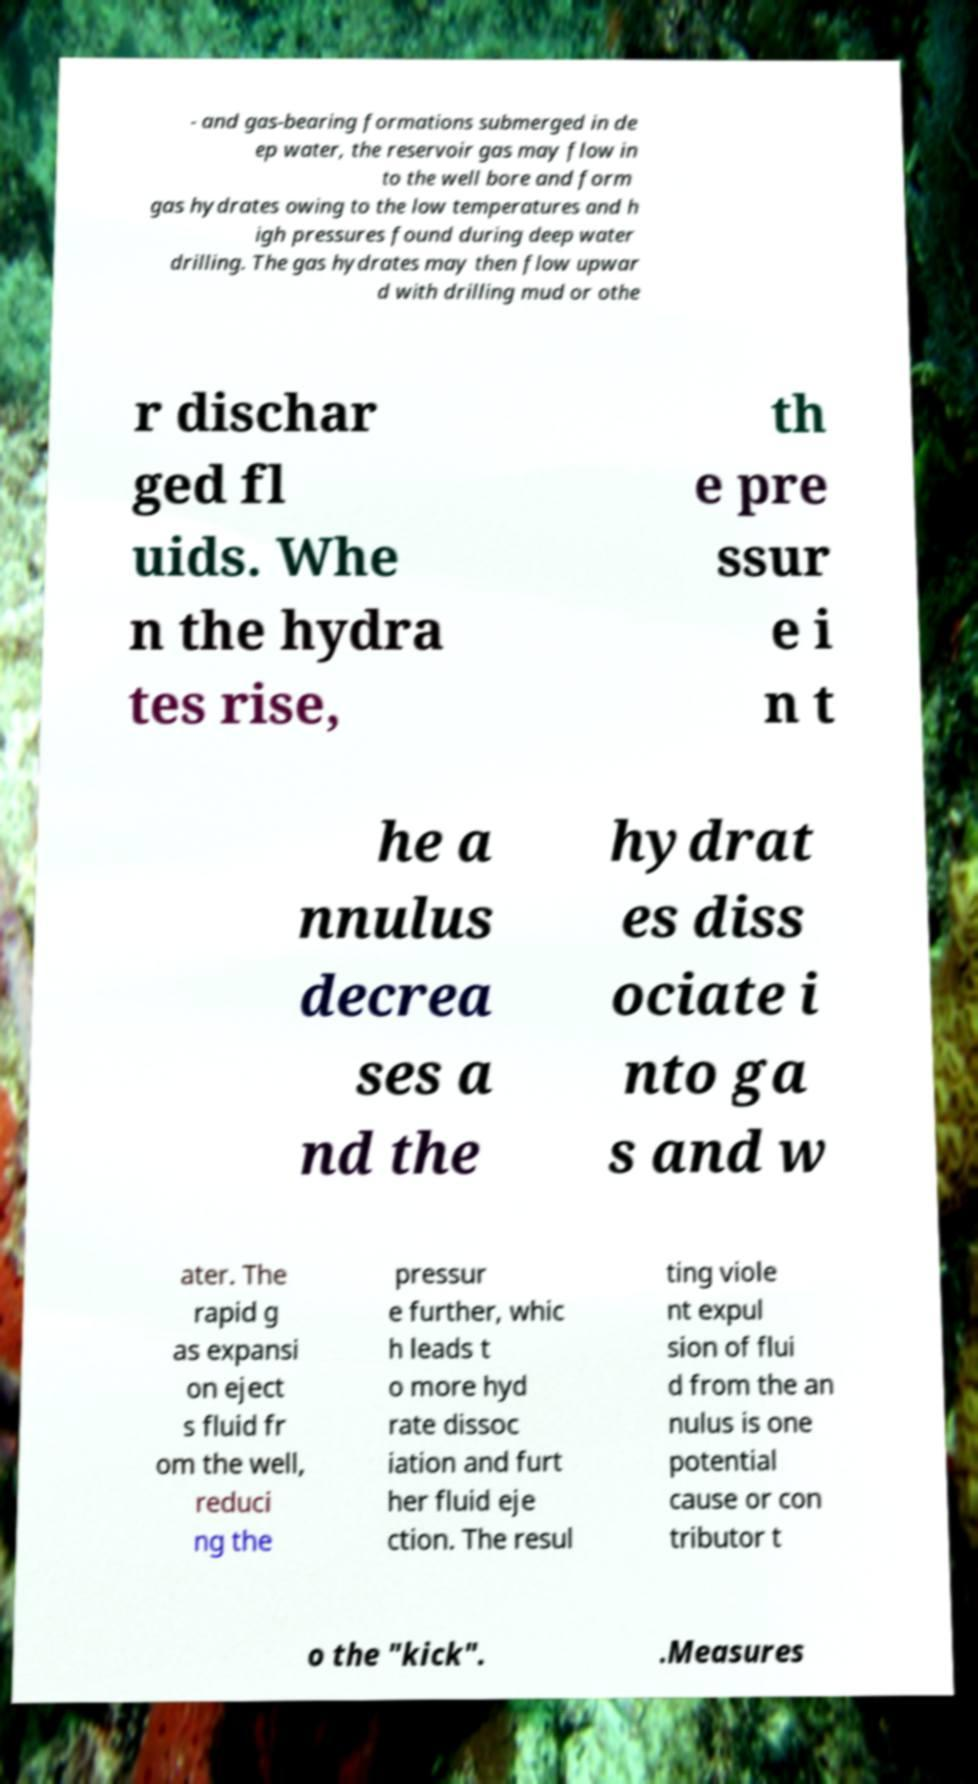Could you assist in decoding the text presented in this image and type it out clearly? - and gas-bearing formations submerged in de ep water, the reservoir gas may flow in to the well bore and form gas hydrates owing to the low temperatures and h igh pressures found during deep water drilling. The gas hydrates may then flow upwar d with drilling mud or othe r dischar ged fl uids. Whe n the hydra tes rise, th e pre ssur e i n t he a nnulus decrea ses a nd the hydrat es diss ociate i nto ga s and w ater. The rapid g as expansi on eject s fluid fr om the well, reduci ng the pressur e further, whic h leads t o more hyd rate dissoc iation and furt her fluid eje ction. The resul ting viole nt expul sion of flui d from the an nulus is one potential cause or con tributor t o the "kick". .Measures 